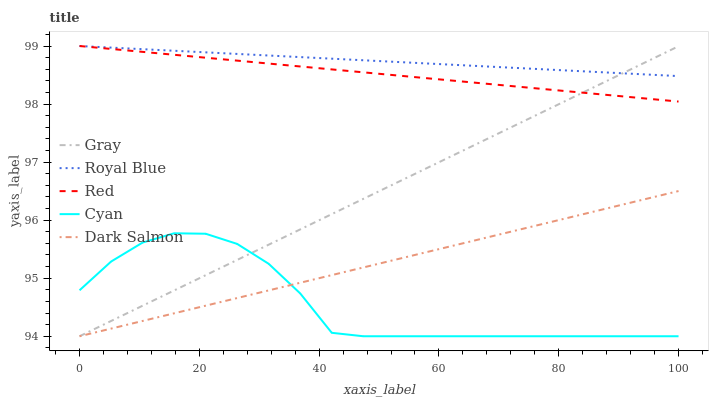Does Cyan have the minimum area under the curve?
Answer yes or no. Yes. Does Royal Blue have the maximum area under the curve?
Answer yes or no. Yes. Does Dark Salmon have the minimum area under the curve?
Answer yes or no. No. Does Dark Salmon have the maximum area under the curve?
Answer yes or no. No. Is Dark Salmon the smoothest?
Answer yes or no. Yes. Is Cyan the roughest?
Answer yes or no. Yes. Is Cyan the smoothest?
Answer yes or no. No. Is Dark Salmon the roughest?
Answer yes or no. No. Does Gray have the lowest value?
Answer yes or no. Yes. Does Red have the lowest value?
Answer yes or no. No. Does Royal Blue have the highest value?
Answer yes or no. Yes. Does Dark Salmon have the highest value?
Answer yes or no. No. Is Dark Salmon less than Royal Blue?
Answer yes or no. Yes. Is Red greater than Dark Salmon?
Answer yes or no. Yes. Does Red intersect Gray?
Answer yes or no. Yes. Is Red less than Gray?
Answer yes or no. No. Is Red greater than Gray?
Answer yes or no. No. Does Dark Salmon intersect Royal Blue?
Answer yes or no. No. 